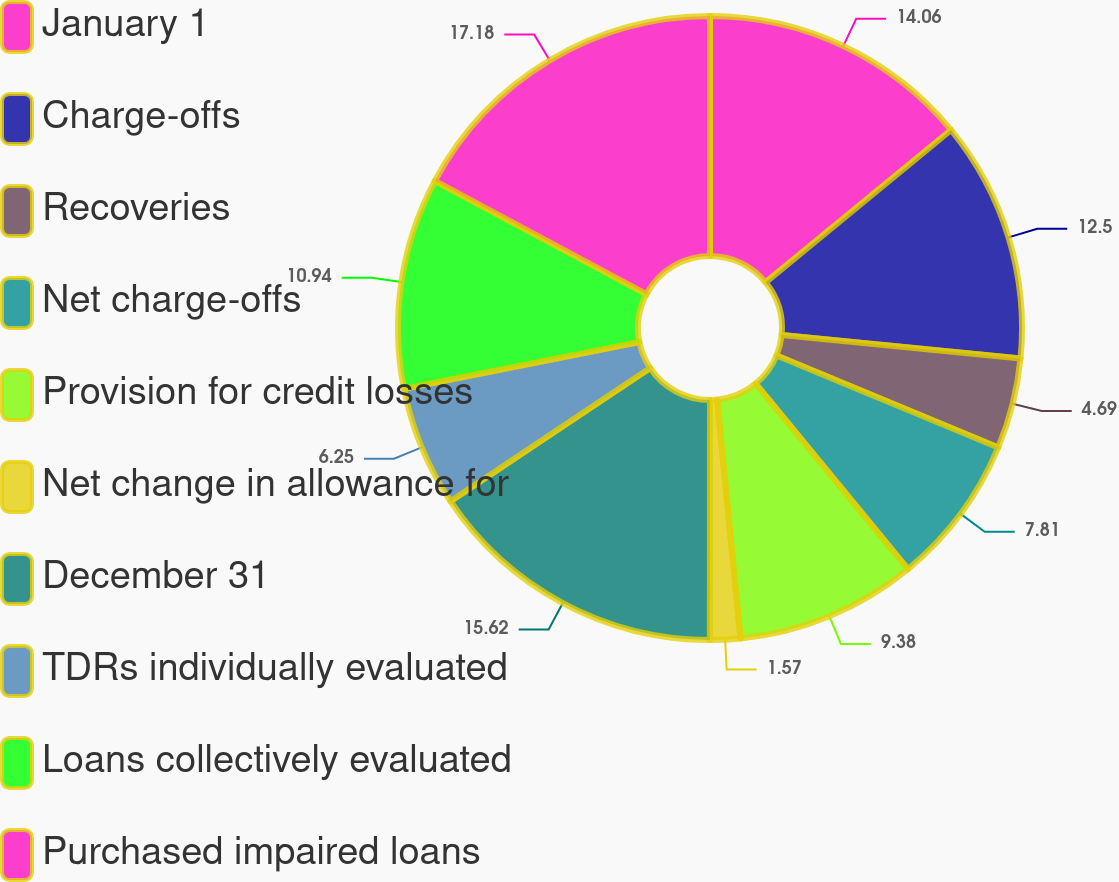Convert chart. <chart><loc_0><loc_0><loc_500><loc_500><pie_chart><fcel>January 1<fcel>Charge-offs<fcel>Recoveries<fcel>Net charge-offs<fcel>Provision for credit losses<fcel>Net change in allowance for<fcel>December 31<fcel>TDRs individually evaluated<fcel>Loans collectively evaluated<fcel>Purchased impaired loans<nl><fcel>14.06%<fcel>12.5%<fcel>4.69%<fcel>7.81%<fcel>9.38%<fcel>1.57%<fcel>15.62%<fcel>6.25%<fcel>10.94%<fcel>17.18%<nl></chart> 